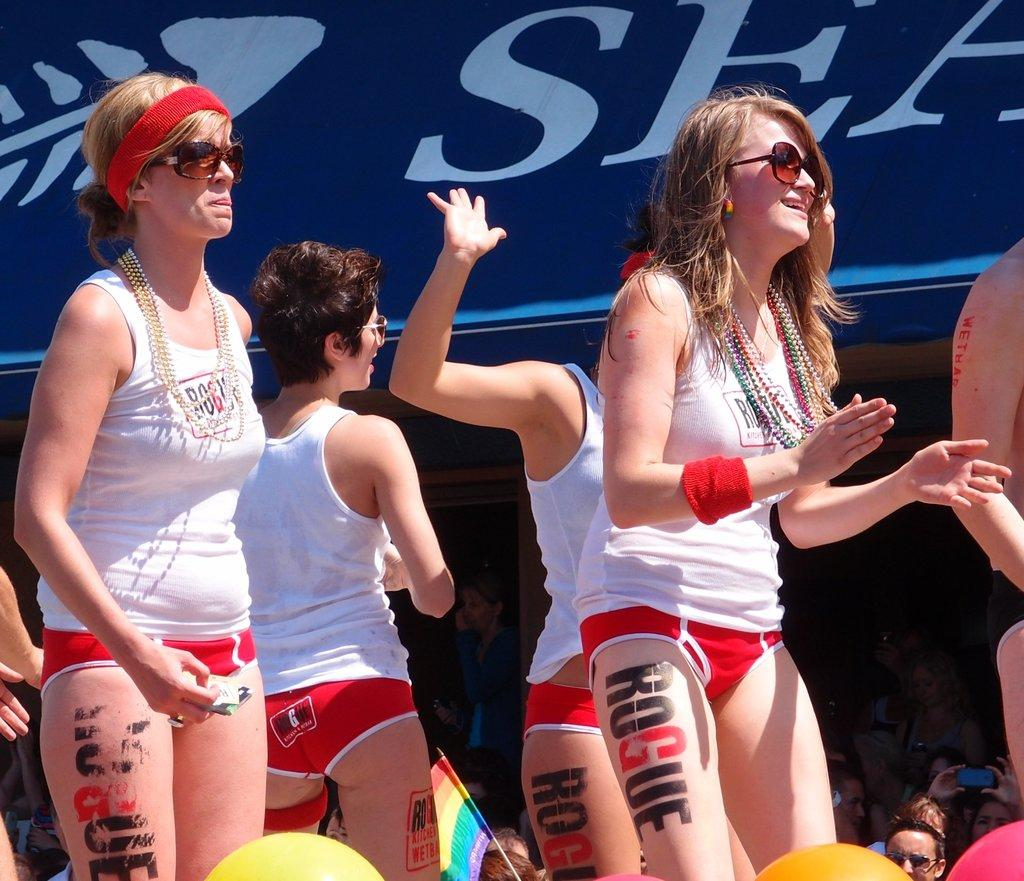What are the people in the image wearing on their faces? The people in the image are wearing goggles. What are the people in the image doing? The people are standing. What else can be seen in the image besides the people? There are objects in the image. What is visible in the background of the image? There is a flag, a group of people, and a banner in the background of the image. How many times does the number 5 appear on the canvas in the image? There is no canvas present in the image, so the number of times the number 5 appears cannot be determined. 